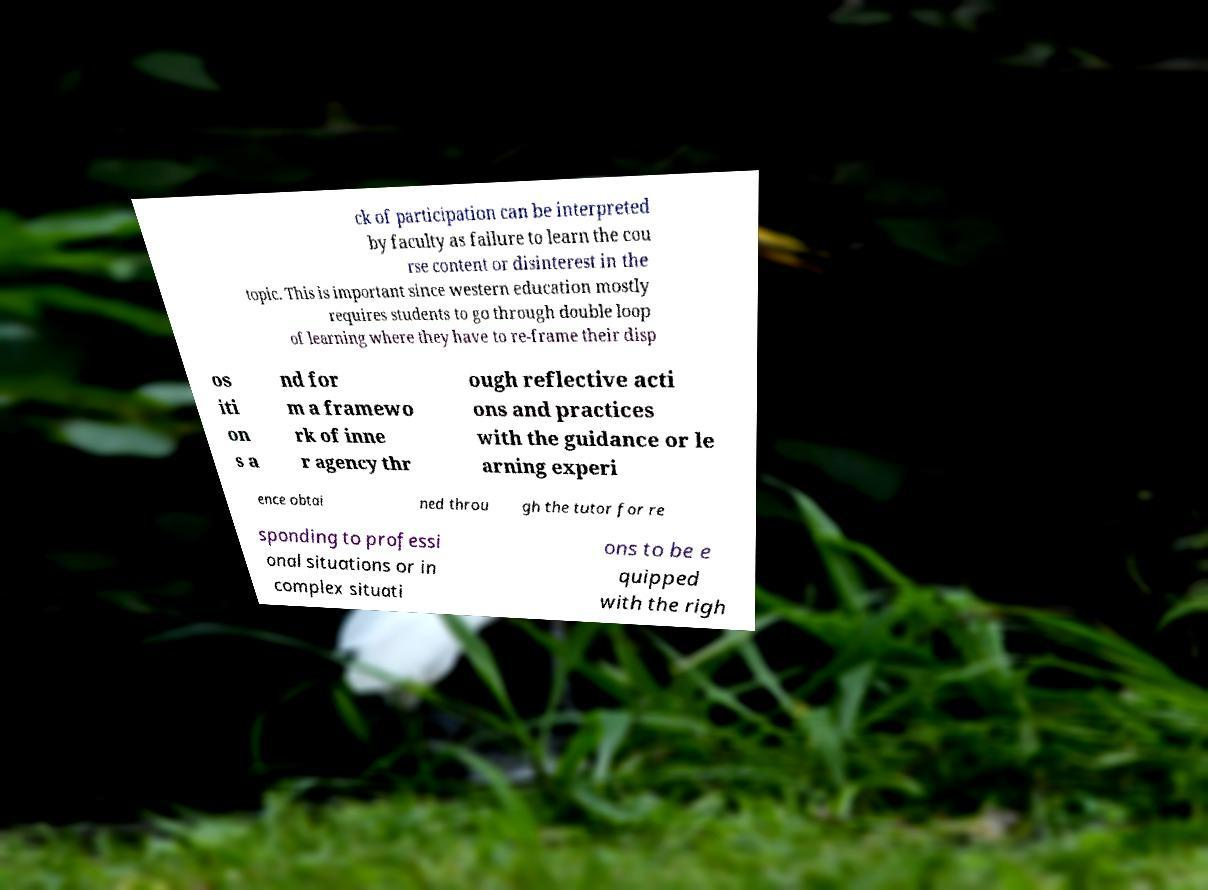Could you extract and type out the text from this image? ck of participation can be interpreted by faculty as failure to learn the cou rse content or disinterest in the topic. This is important since western education mostly requires students to go through double loop of learning where they have to re-frame their disp os iti on s a nd for m a framewo rk of inne r agency thr ough reflective acti ons and practices with the guidance or le arning experi ence obtai ned throu gh the tutor for re sponding to professi onal situations or in complex situati ons to be e quipped with the righ 